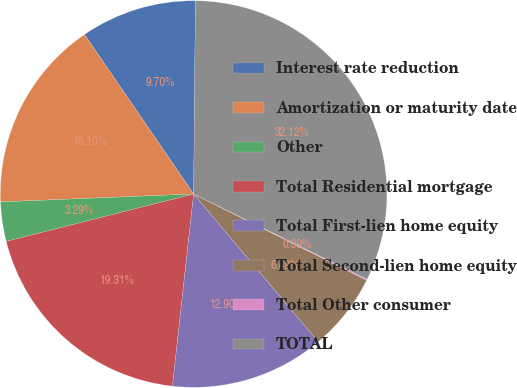<chart> <loc_0><loc_0><loc_500><loc_500><pie_chart><fcel>Interest rate reduction<fcel>Amortization or maturity date<fcel>Other<fcel>Total Residential mortgage<fcel>Total First-lien home equity<fcel>Total Second-lien home equity<fcel>Total Other consumer<fcel>TOTAL<nl><fcel>9.7%<fcel>16.1%<fcel>3.29%<fcel>19.31%<fcel>12.9%<fcel>6.49%<fcel>0.09%<fcel>32.12%<nl></chart> 